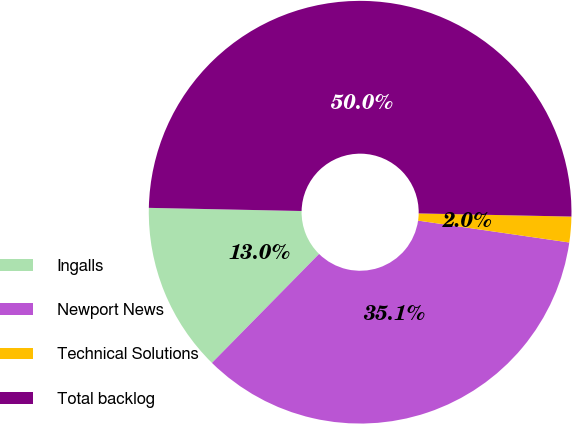Convert chart to OTSL. <chart><loc_0><loc_0><loc_500><loc_500><pie_chart><fcel>Ingalls<fcel>Newport News<fcel>Technical Solutions<fcel>Total backlog<nl><fcel>12.96%<fcel>35.08%<fcel>1.96%<fcel>50.0%<nl></chart> 